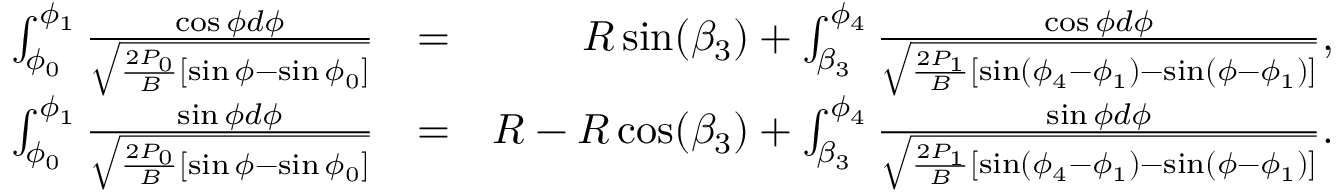Convert formula to latex. <formula><loc_0><loc_0><loc_500><loc_500>\begin{array} { r l r } { \int _ { \phi _ { 0 } } ^ { \phi _ { 1 } } \frac { \cos \phi d \phi } { \sqrt { \frac { 2 P _ { 0 } } { B } [ \sin \phi - \sin \phi _ { 0 } ] } } } & { = } & { R \sin ( \beta _ { 3 } ) + \int _ { \beta _ { 3 } } ^ { \phi _ { 4 } } \frac { \cos \phi d \phi } { \sqrt { \frac { 2 P _ { 1 } } { B } [ \sin ( \phi _ { 4 } - \phi _ { 1 } ) - \sin ( \phi - \phi _ { 1 } ) ] } } , } \\ { \int _ { \phi _ { 0 } } ^ { \phi _ { 1 } } \frac { \sin \phi d \phi } { \sqrt { \frac { 2 P _ { 0 } } { B } [ \sin \phi - \sin \phi _ { 0 } ] } } } & { = } & { R - R \cos ( \beta _ { 3 } ) + \int _ { \beta _ { 3 } } ^ { \phi _ { 4 } } \frac { \sin \phi d \phi } { \sqrt { \frac { 2 P _ { 1 } } { B } [ \sin ( \phi _ { 4 } - \phi _ { 1 } ) - \sin ( \phi - \phi _ { 1 } ) ] } } . } \end{array}</formula> 